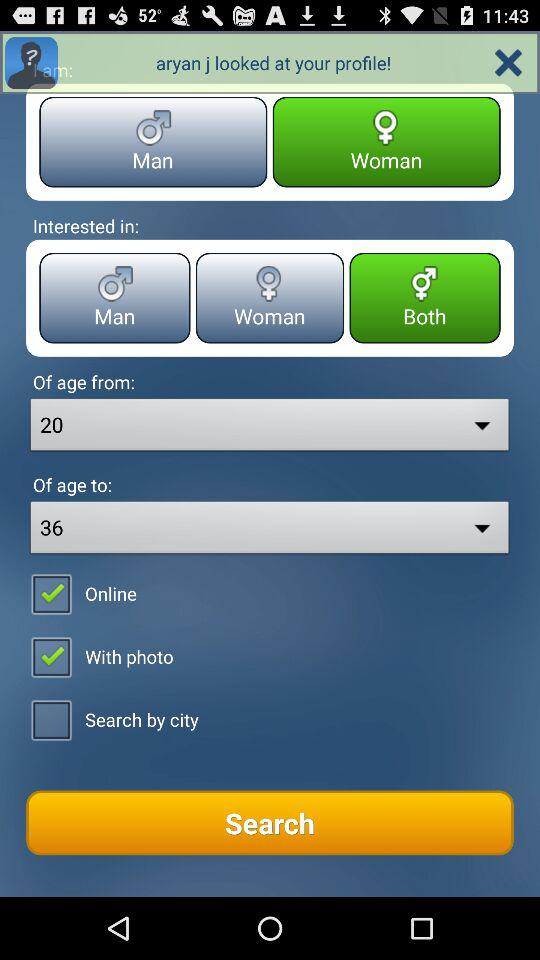Which option is selected in "Interested in"? The selected option is "Both". 